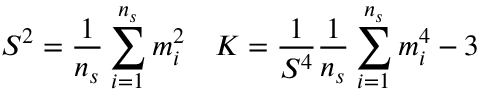<formula> <loc_0><loc_0><loc_500><loc_500>S ^ { 2 } = \frac { 1 } { n _ { s } } \sum _ { i = 1 } ^ { n _ { s } } m _ { i } ^ { 2 } \quad K = \frac { 1 } { S ^ { 4 } } \frac { 1 } { n _ { s } } \sum _ { i = 1 } ^ { n _ { s } } m _ { i } ^ { 4 } - 3</formula> 